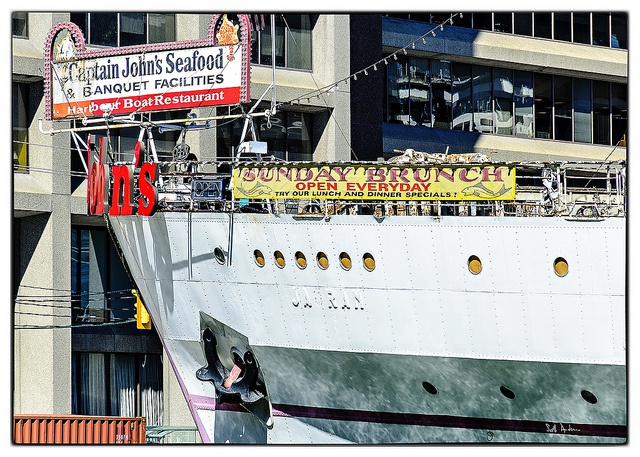Describe the objects in this image and their specific colors. I can see a boat in white, teal, darkgray, and black tones in this image. 